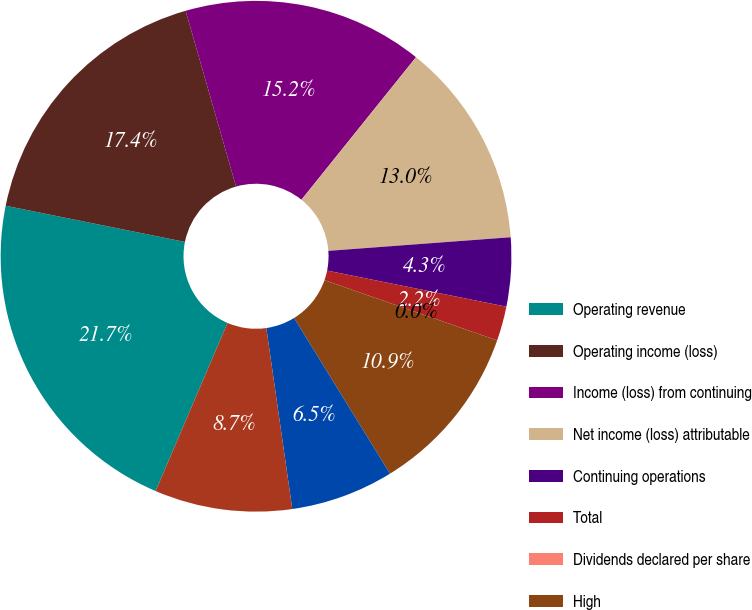Convert chart. <chart><loc_0><loc_0><loc_500><loc_500><pie_chart><fcel>Operating revenue<fcel>Operating income (loss)<fcel>Income (loss) from continuing<fcel>Net income (loss) attributable<fcel>Continuing operations<fcel>Total<fcel>Dividends declared per share<fcel>High<fcel>Low<fcel>Close<nl><fcel>21.74%<fcel>17.39%<fcel>15.22%<fcel>13.04%<fcel>4.35%<fcel>2.18%<fcel>0.0%<fcel>10.87%<fcel>6.52%<fcel>8.7%<nl></chart> 